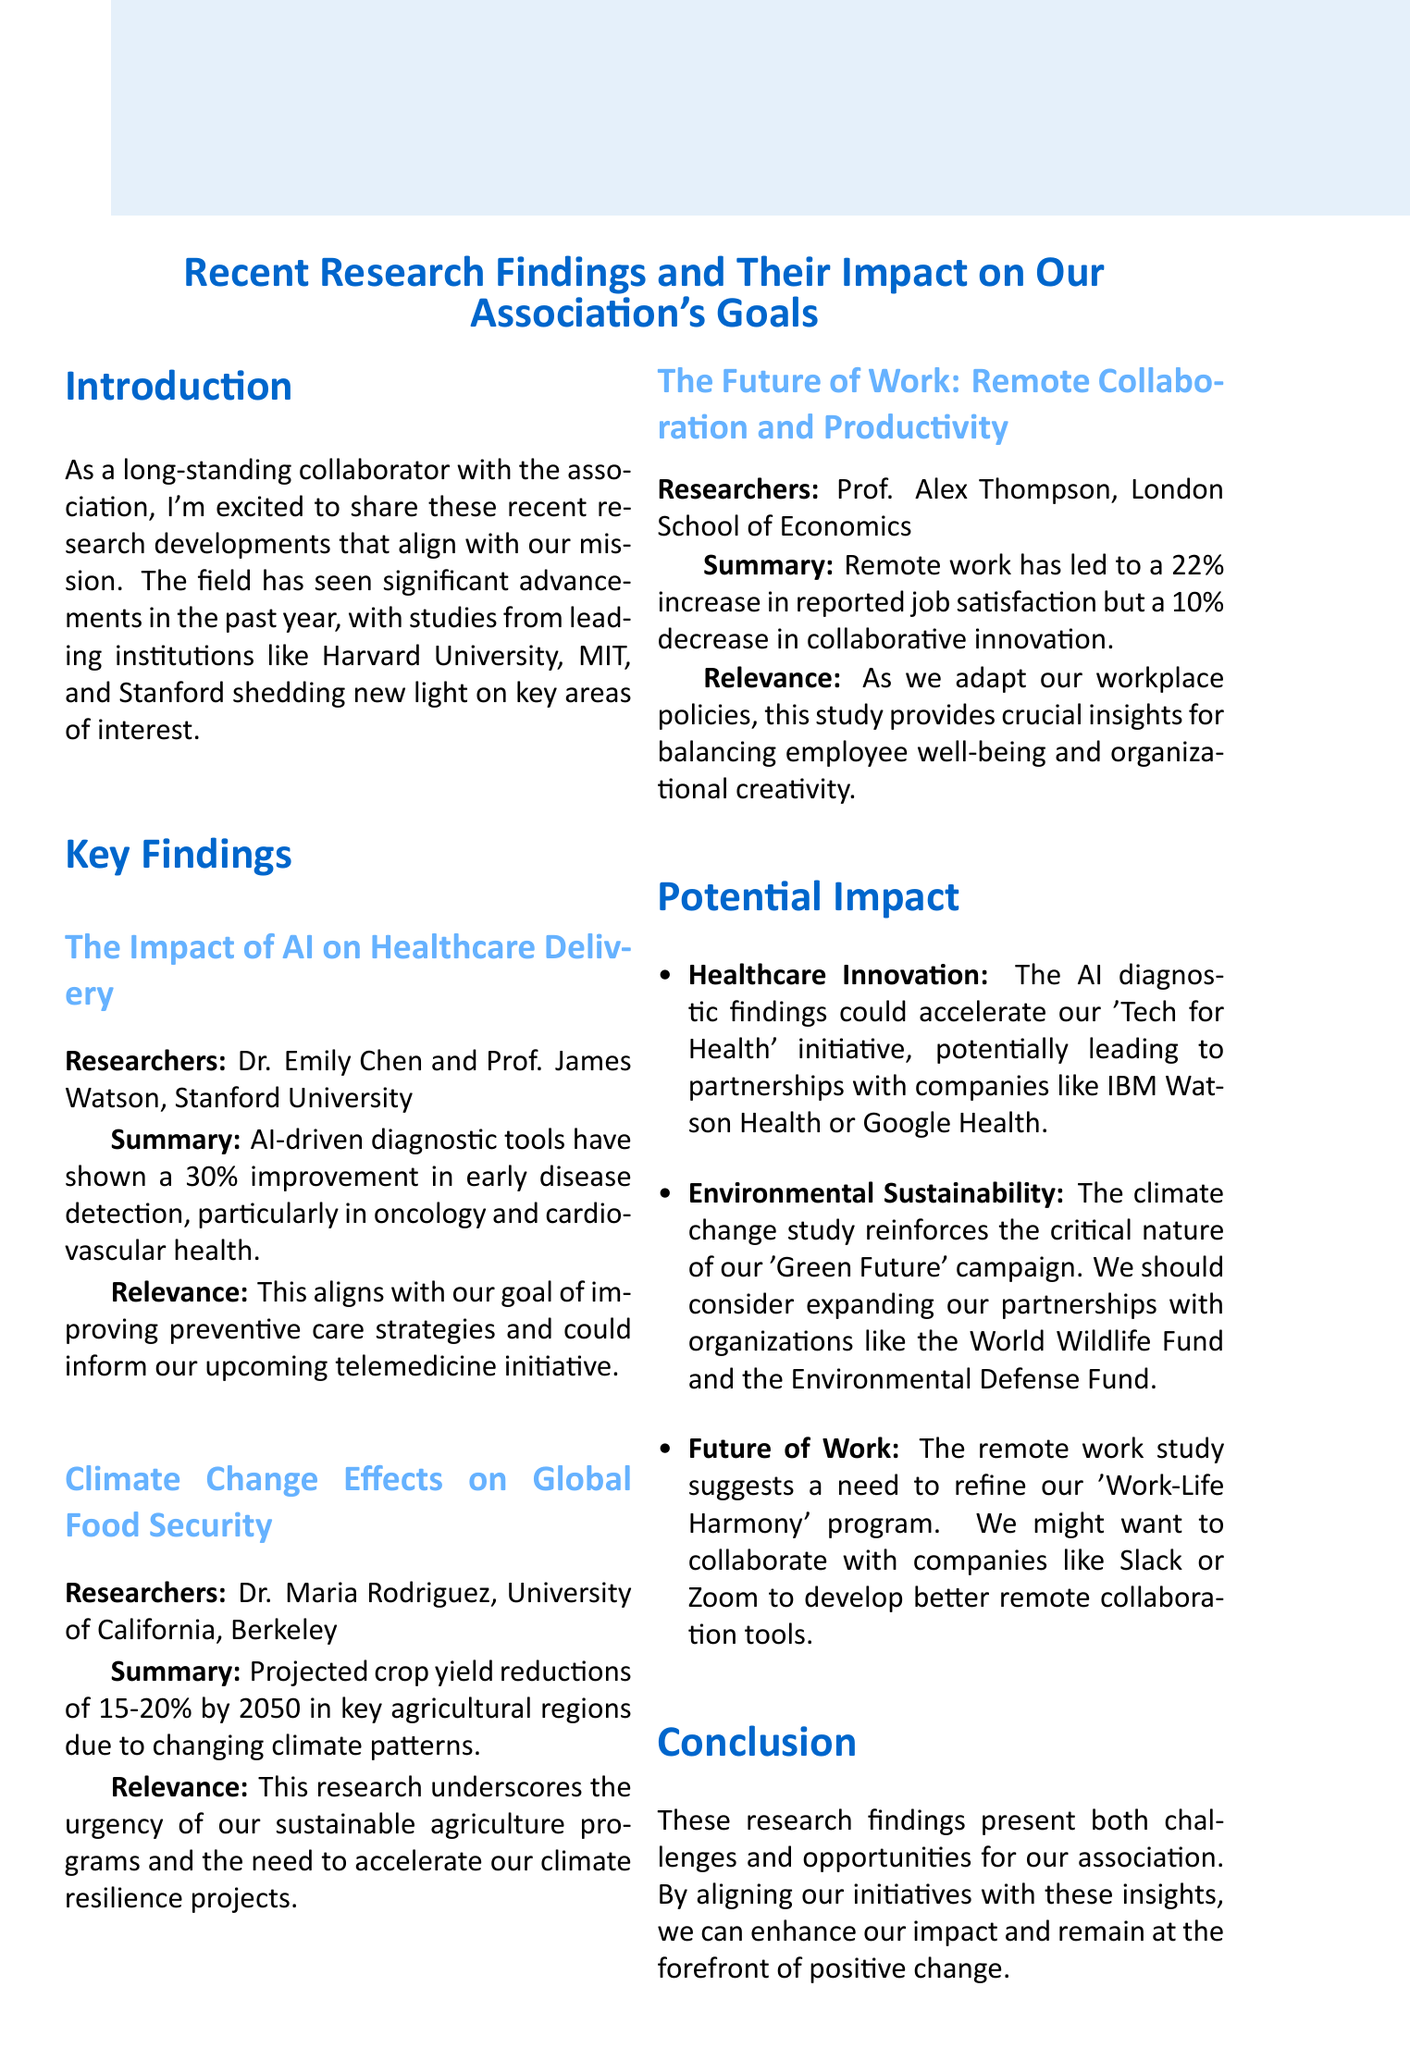what is the title of the memo? The title of the memo is stated at the beginning.
Answer: Recent Research Findings and Their Impact on Our Association's Goals who conducted the study on AI and healthcare delivery? The names of the researchers are provided in the key findings section.
Answer: Dr. Emily Chen and Prof. James Watson what percentage improvement in early disease detection was reported in the AI study? The summary of the AI study mentions the improvement percentage directly.
Answer: 30% which agricultural regions are projected to have crop yield reductions? The climate change study lists the affected regions in its summary.
Answer: Key agricultural regions what is the projected crop yield reduction by 2050 according to the climate change study? The summary provides the projected reduction percentage for clarity.
Answer: 15-20% which initiative could the AI findings accelerate? The potential impact section identifies the specific initiative linked to the findings.
Answer: Tech for Health what was the reported increase in job satisfaction from remote work? The summary of the remote work study mentions the percentage increase directly.
Answer: 22% which organization is mentioned as a potential partner for climate resilience projects? The potential impact section highlights possible organizational partnerships.
Answer: World Wildlife Fund what action item is proposed regarding the AI findings? The potential impact section outlines specific action items to be taken.
Answer: Propose a task force to explore AI integration in our healthcare projects 